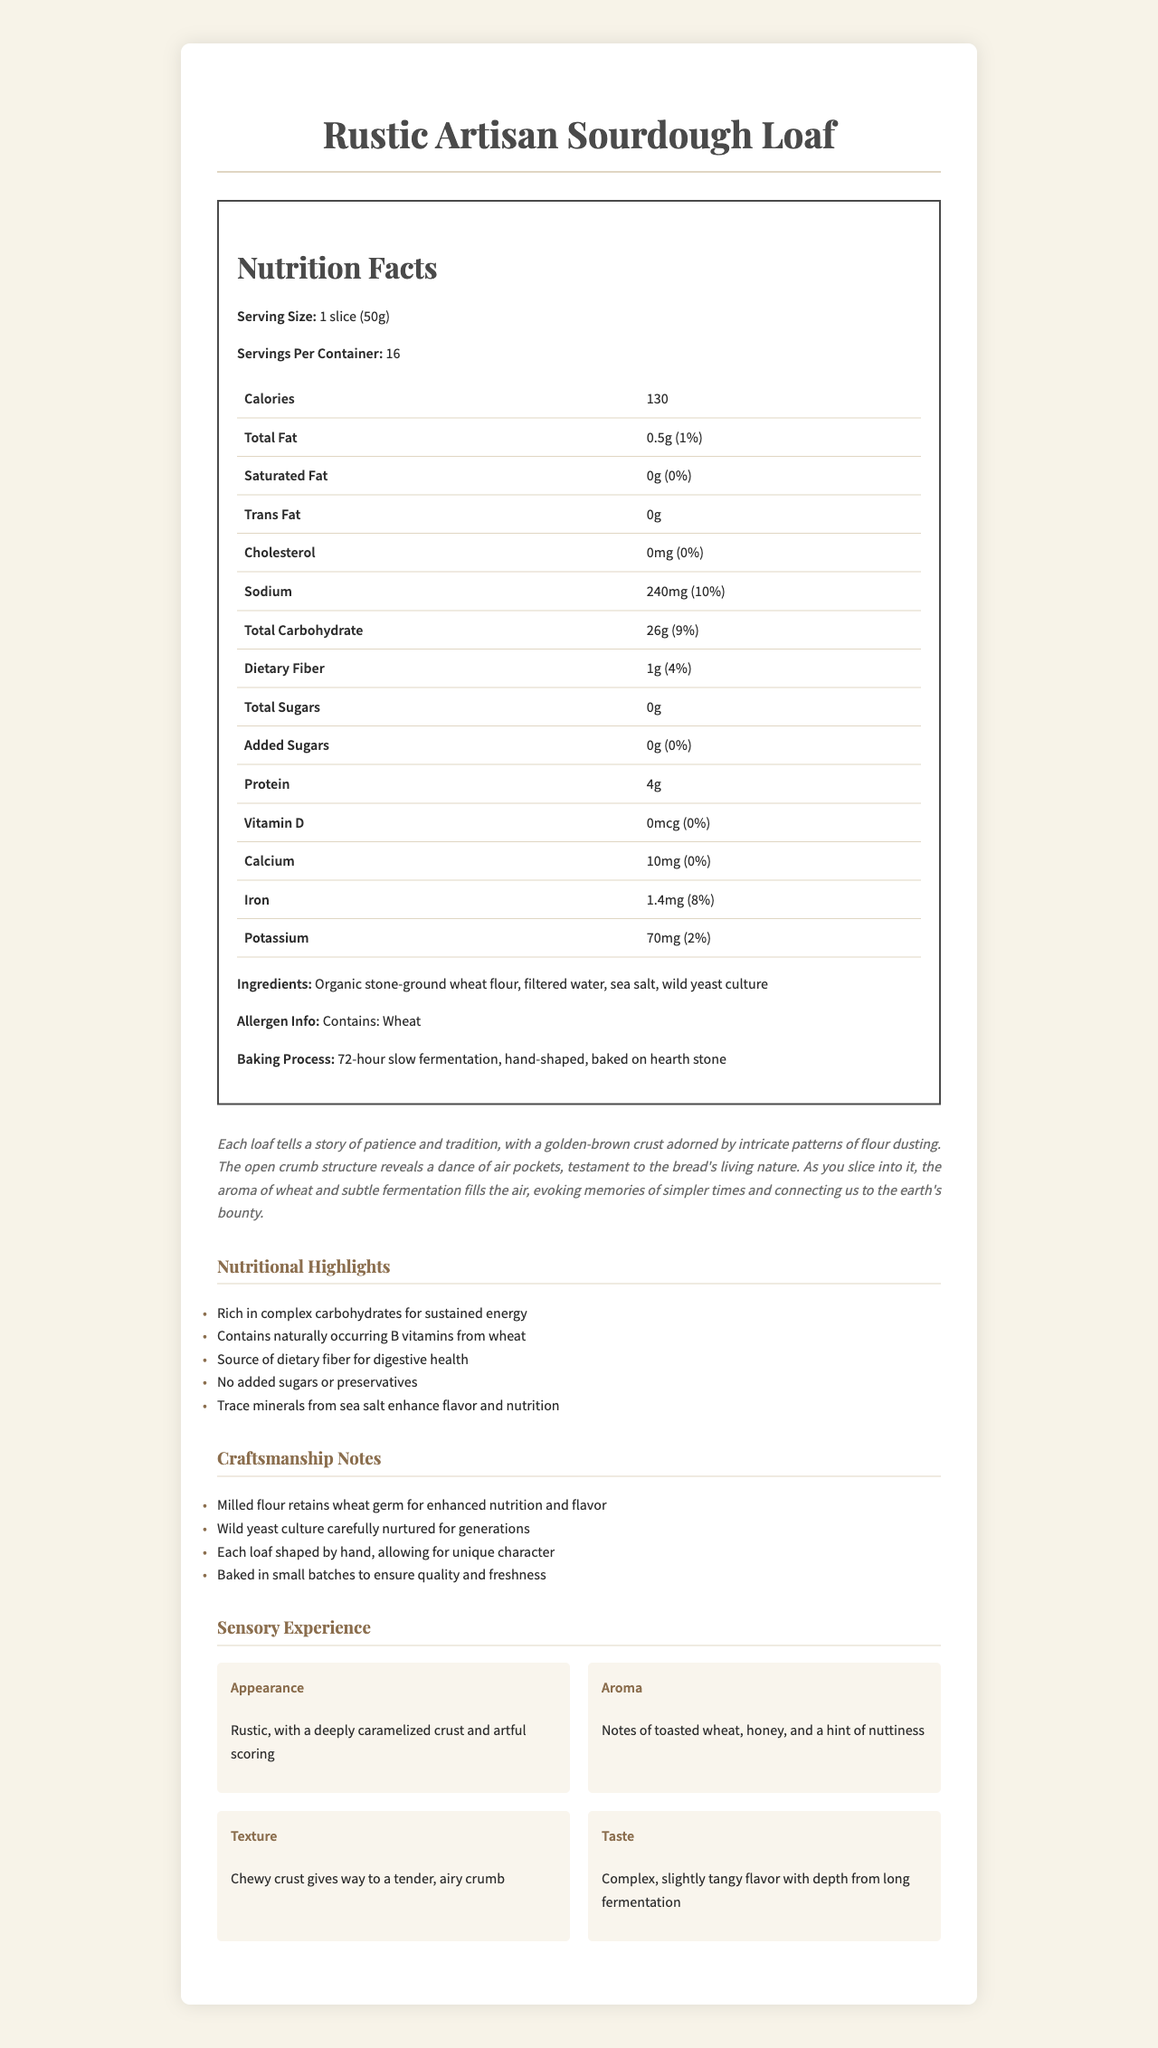How many calories are in one serving? The document explicitly states that each serving contains 130 calories.
Answer: 130 What is the serving size of the Rustic Artisan Sourdough Loaf? The serving size is clearly specified as "1 slice (50g)" in the document.
Answer: 1 slice (50g) What percentage of the daily value of sodium does one serving provide? According to the document, one serving provides 10% of the daily value for sodium.
Answer: 10% What are the main ingredients listed for the Rustic Artisan Sourdough Loaf? These ingredients are listed in the section specifying the ingredients.
Answer: Organic stone-ground wheat flour, filtered water, sea salt, wild yeast culture Which nutrient has the highest daily value percentage in one serving? The sodium content is 10% of the daily value, which is the highest among the listed nutrients.
Answer: Sodium Which of the following sensory aspects is associated with "complex, slightly tangy flavor with depth from long fermentation"? A. Appearance B. Aroma C. Texture D. Taste The document specifies that the complex, slightly tangy flavor is associated with "Taste".
Answer: D Based on the document, which nutrients have a 0% daily value in one serving? I. Saturated Fat II. Cholesterol III. Vitamin D IV. Calcium The document mentions that Saturated Fat, Cholesterol, and Vitamin D all have a 0% daily value.
Answer: I, II, and III Does the document indicate that the Rustic Artisan Sourdough Loaf contains added sugars? The document states that the bread contains 0g of added sugars, thus indicating it does not contain added sugars.
Answer: No Summarize the key points of the document. The document is a comprehensive overview of the Rustic Artisan Sourdough Loaf, covering nutritional information, ingredients, craftsmanship, and sensory attributes, reflecting the bread's artisanal quality and nutritional benefits.
Answer: The document provides a detailed nutritional breakdown of the Rustic Artisan Sourdough Loaf, highlighting its handcrafted nature and wholesome ingredients. It lists serving size, calories, macro and micronutrients, ingredients, and allergen information. Additionally, it includes an artistic description of the bread's appearance, aroma, texture, and taste, along with its sensory experience, nutritional highlights, and craftsmanship notes. Is the Rustic Artisan Sourdough Loaf gluten-free? The document states that it contains wheat, but it does not explicitly state whether it is gluten-free; typically, products containing wheat are not gluten-free, but the document does not explicitly confirm this.
Answer: Not enough information 